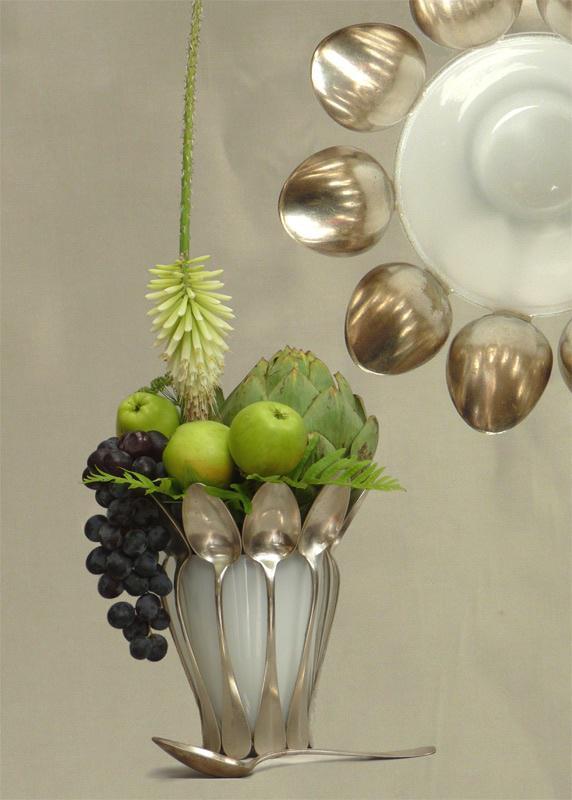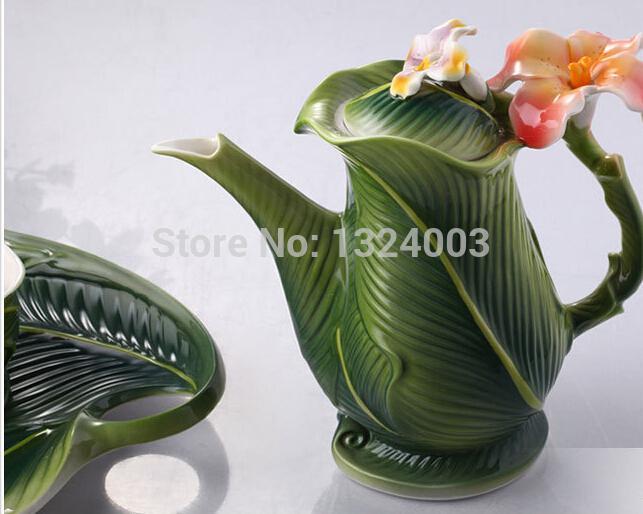The first image is the image on the left, the second image is the image on the right. For the images shown, is this caption "Two artichoke shaped vases contain plants." true? Answer yes or no. No. The first image is the image on the left, the second image is the image on the right. For the images displayed, is the sentence "The left image contains an entirely green plant in an artichoke-shaped vase, and the right image contains a purple-flowered plant in an artichoke-shaped vase." factually correct? Answer yes or no. No. 